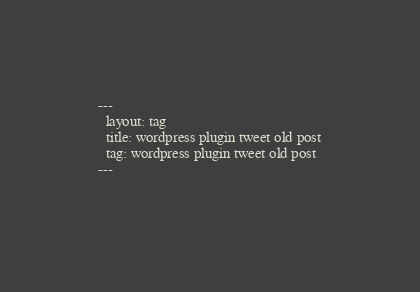Convert code to text. <code><loc_0><loc_0><loc_500><loc_500><_HTML_>---
  layout: tag
  title: wordpress plugin tweet old post
  tag: wordpress plugin tweet old post
---
  </code> 